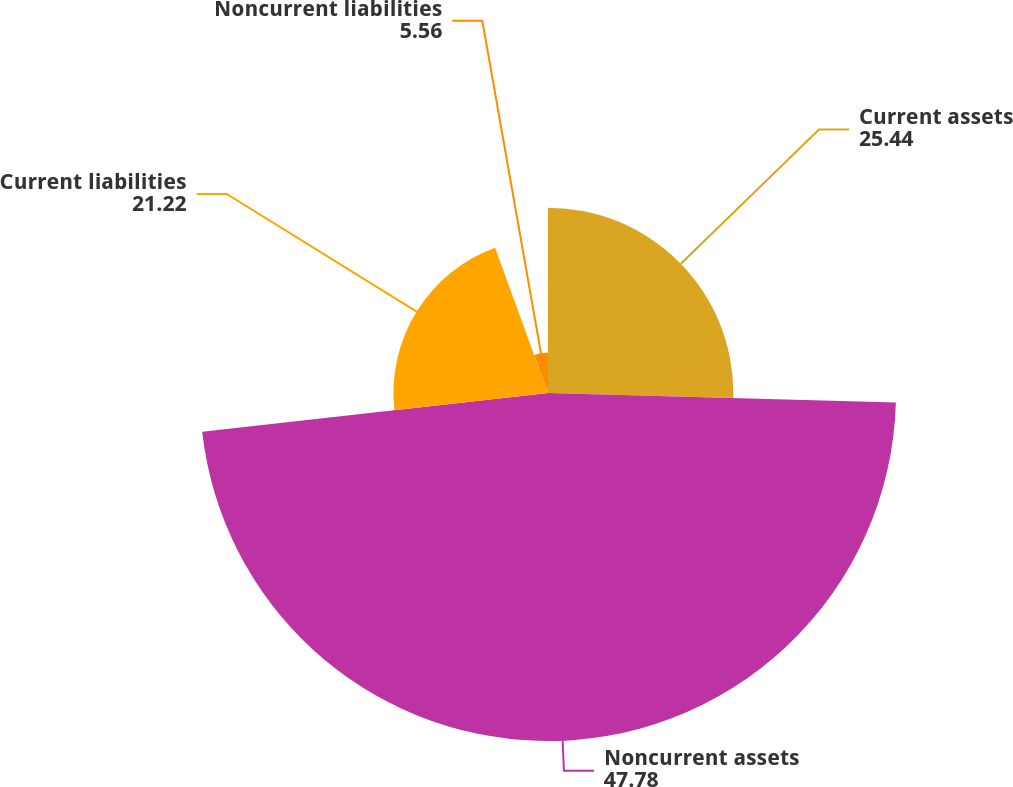Convert chart to OTSL. <chart><loc_0><loc_0><loc_500><loc_500><pie_chart><fcel>Current assets<fcel>Noncurrent assets<fcel>Current liabilities<fcel>Noncurrent liabilities<nl><fcel>25.44%<fcel>47.78%<fcel>21.22%<fcel>5.56%<nl></chart> 